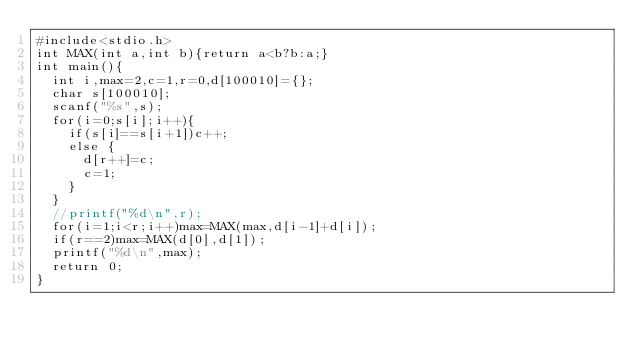<code> <loc_0><loc_0><loc_500><loc_500><_C_>#include<stdio.h>
int MAX(int a,int b){return a<b?b:a;}
int main(){
  int i,max=2,c=1,r=0,d[100010]={};
  char s[100010];
  scanf("%s",s);
  for(i=0;s[i];i++){
    if(s[i]==s[i+1])c++;
    else {
      d[r++]=c;
      c=1;
    }
  }
  //printf("%d\n",r);
  for(i=1;i<r;i++)max=MAX(max,d[i-1]+d[i]);
  if(r==2)max=MAX(d[0],d[1]);
  printf("%d\n",max);
  return 0;
}
</code> 